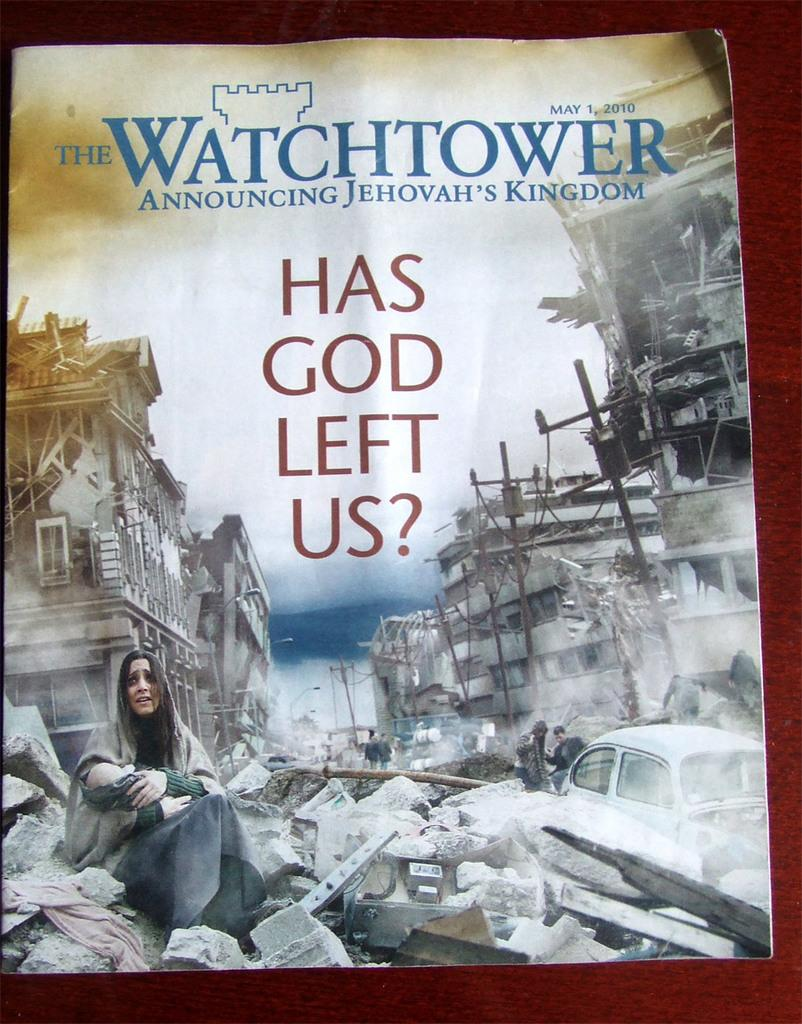<image>
Relay a brief, clear account of the picture shown. The cover of a magazine titled, The Watchtower. 